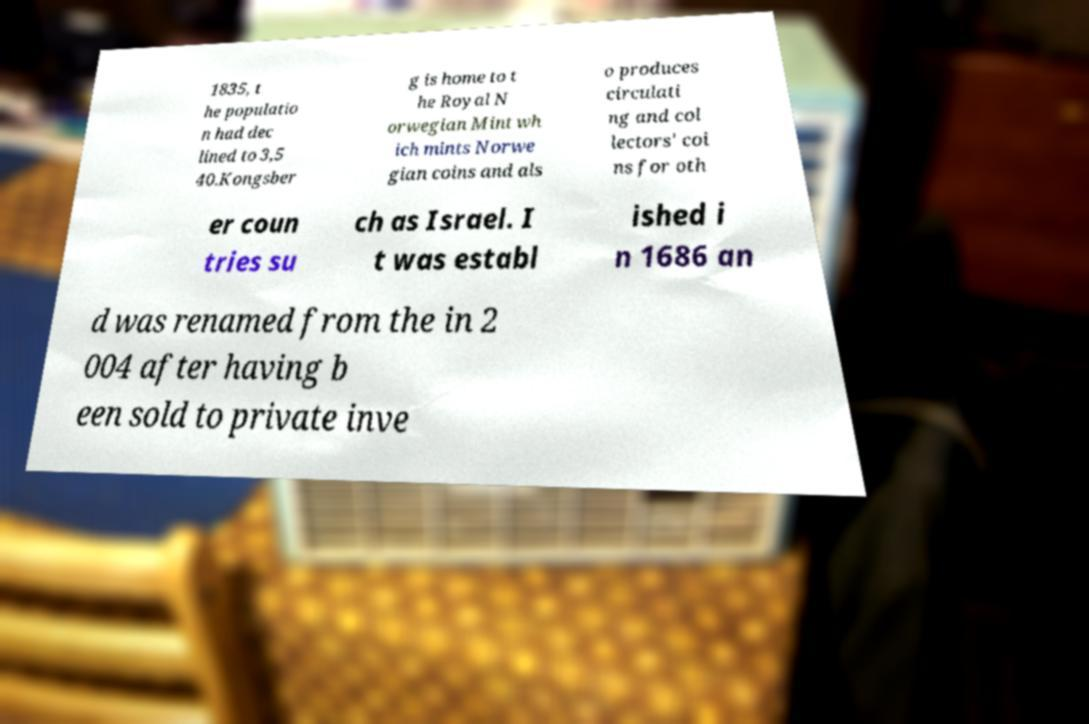Please read and relay the text visible in this image. What does it say? 1835, t he populatio n had dec lined to 3,5 40.Kongsber g is home to t he Royal N orwegian Mint wh ich mints Norwe gian coins and als o produces circulati ng and col lectors' coi ns for oth er coun tries su ch as Israel. I t was establ ished i n 1686 an d was renamed from the in 2 004 after having b een sold to private inve 